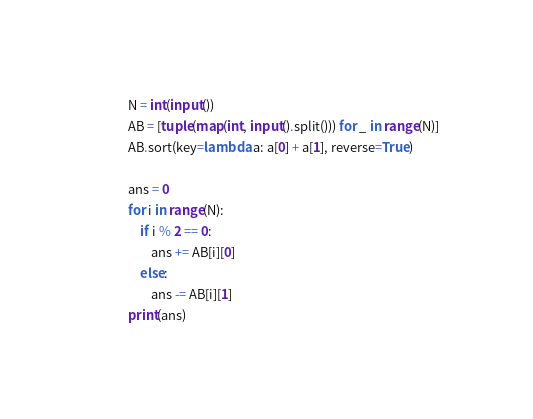<code> <loc_0><loc_0><loc_500><loc_500><_Python_>N = int(input())
AB = [tuple(map(int, input().split())) for _ in range(N)]
AB.sort(key=lambda a: a[0] + a[1], reverse=True)

ans = 0
for i in range(N):
    if i % 2 == 0:
        ans += AB[i][0]
    else:
        ans -= AB[i][1]
print(ans)
</code> 